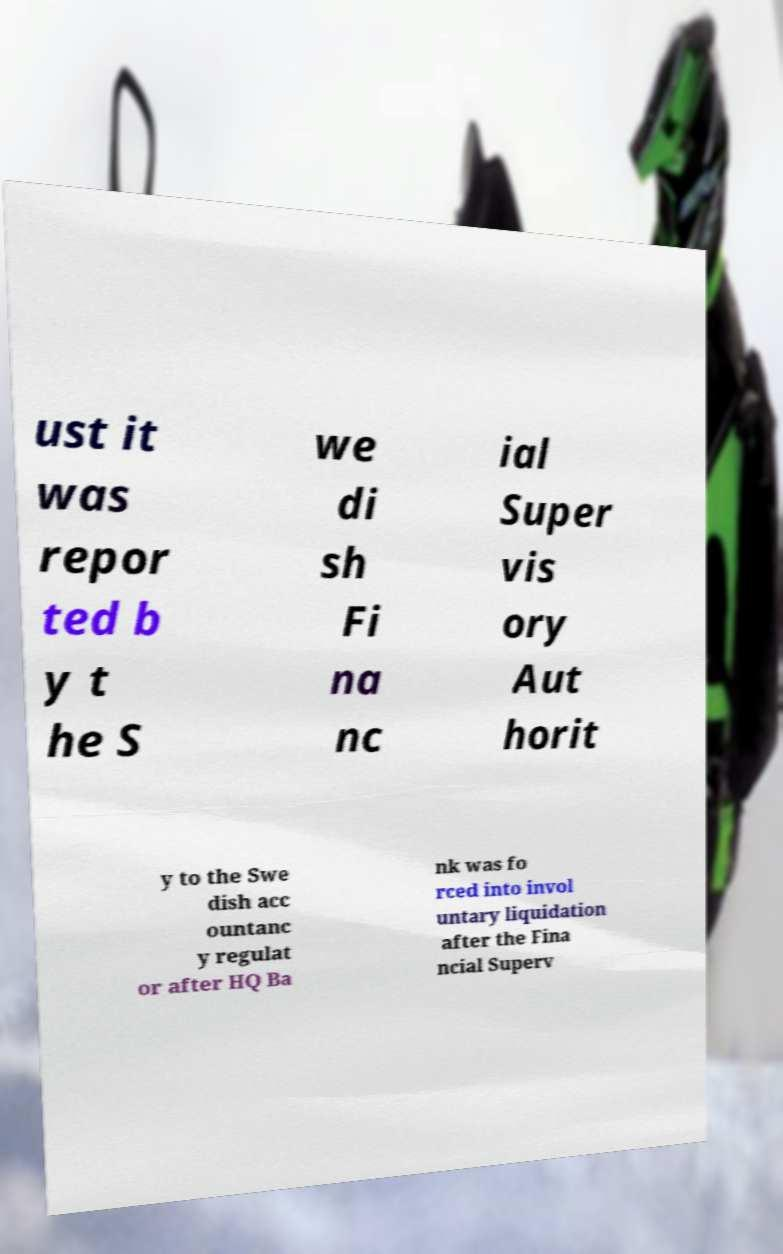What messages or text are displayed in this image? I need them in a readable, typed format. ust it was repor ted b y t he S we di sh Fi na nc ial Super vis ory Aut horit y to the Swe dish acc ountanc y regulat or after HQ Ba nk was fo rced into invol untary liquidation after the Fina ncial Superv 